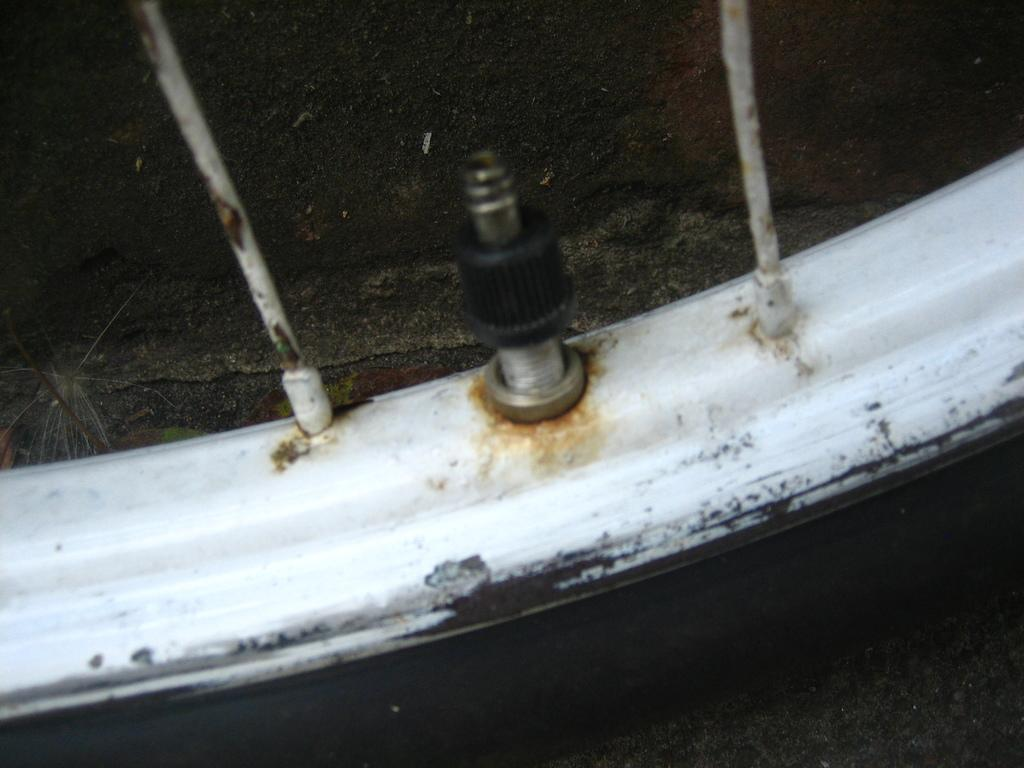What part of a bicycle is visible in the image? There is a wheel of a bicycle in the image. Can you see any giants riding the bicycle in the image? There are no giants or any other riders visible in the image; it only features the wheel of a bicycle. 